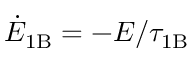Convert formula to latex. <formula><loc_0><loc_0><loc_500><loc_500>\dot { E } _ { 1 B } = - E / \tau _ { 1 B }</formula> 